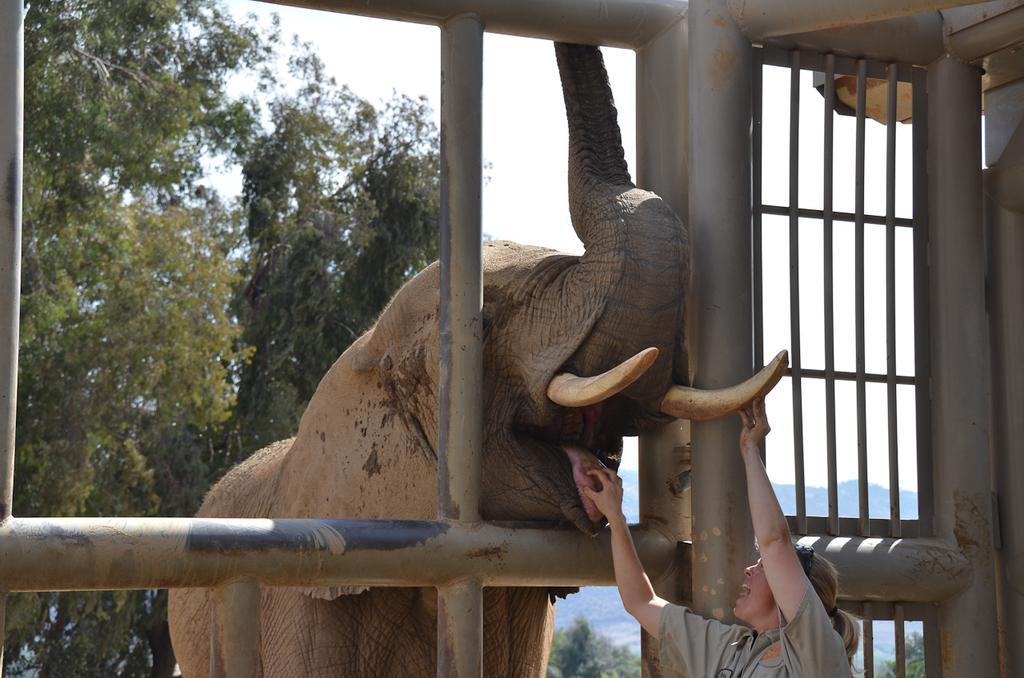Describe this image in one or two sentences. In the image in the center we can see fence,one elephant and one woman standing and holding elephant tongue. In the background we can see sky,clouds,hill and trees. 